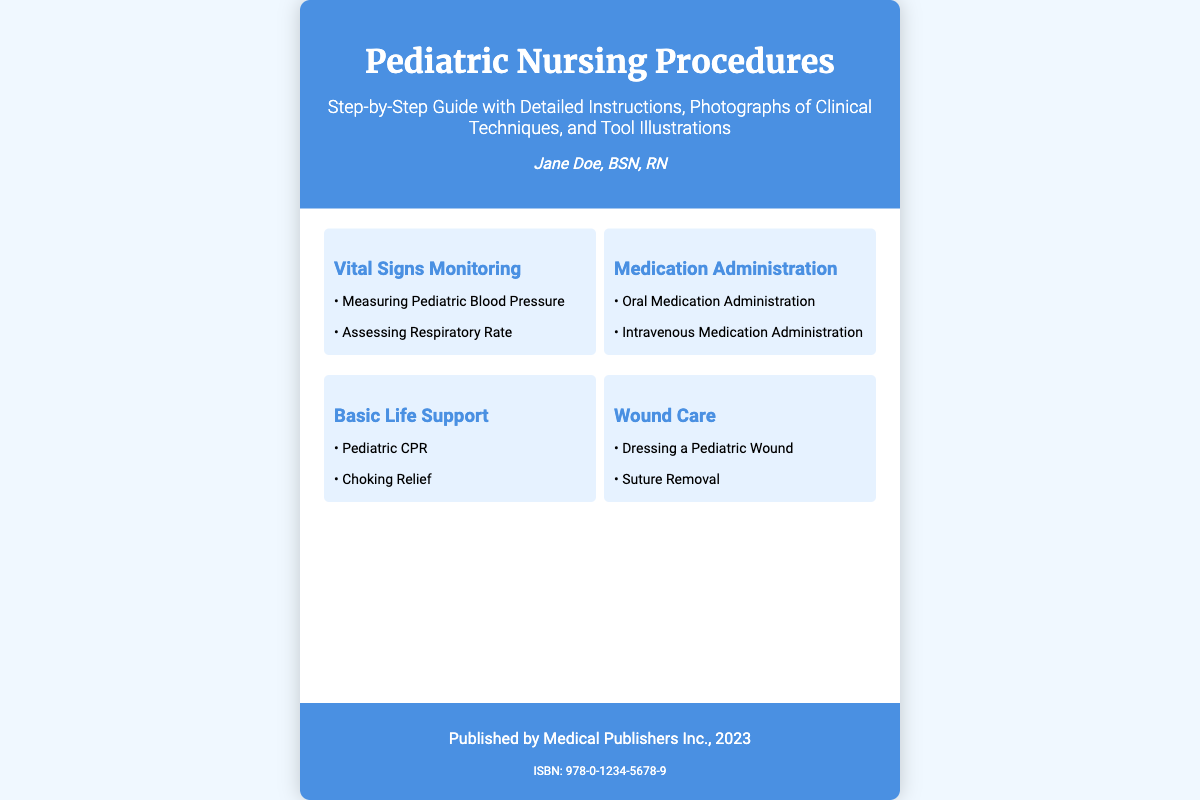What is the title of the book? The title is prominently displayed at the top of the document, indicating the main subject matter.
Answer: Pediatric Nursing Procedures Who is the author? The author's name is mentioned in the author section below the title.
Answer: Jane Doe, BSN, RN What type of guide is this book described as? The subtitle elaborates on the nature of the guide provided in the book cover.
Answer: Step-by-Step Guide What is one procedure included in the section on Vital Signs Monitoring? The section lists specific procedures under Vital Signs Monitoring.
Answer: Measuring Pediatric Blood Pressure How many sections are listed in the content? The document outlines multiple sections in the content area, detailing different nursing procedures.
Answer: Four What is the ISBN number of the book? The ISBN is provided in the footer section for identification purposes.
Answer: 978-0-1234-5678-9 Which organization published the book? The publisher is mentioned in the footer of the document.
Answer: Medical Publishers Inc What is the background color of the book cover? The background color is specified in the CSS styling for the overall layout.
Answer: #f0f8ff 